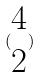<formula> <loc_0><loc_0><loc_500><loc_500>( \begin{matrix} 4 \\ 2 \end{matrix} )</formula> 